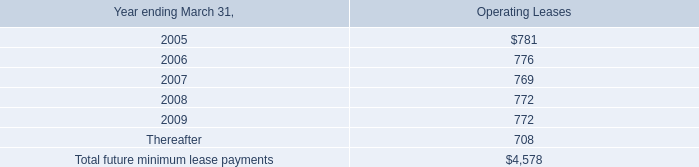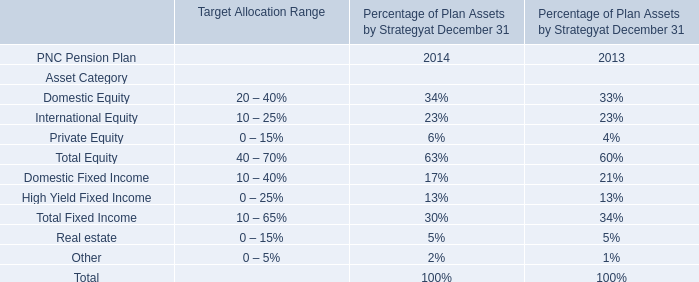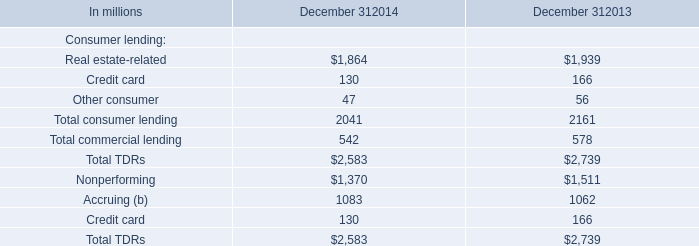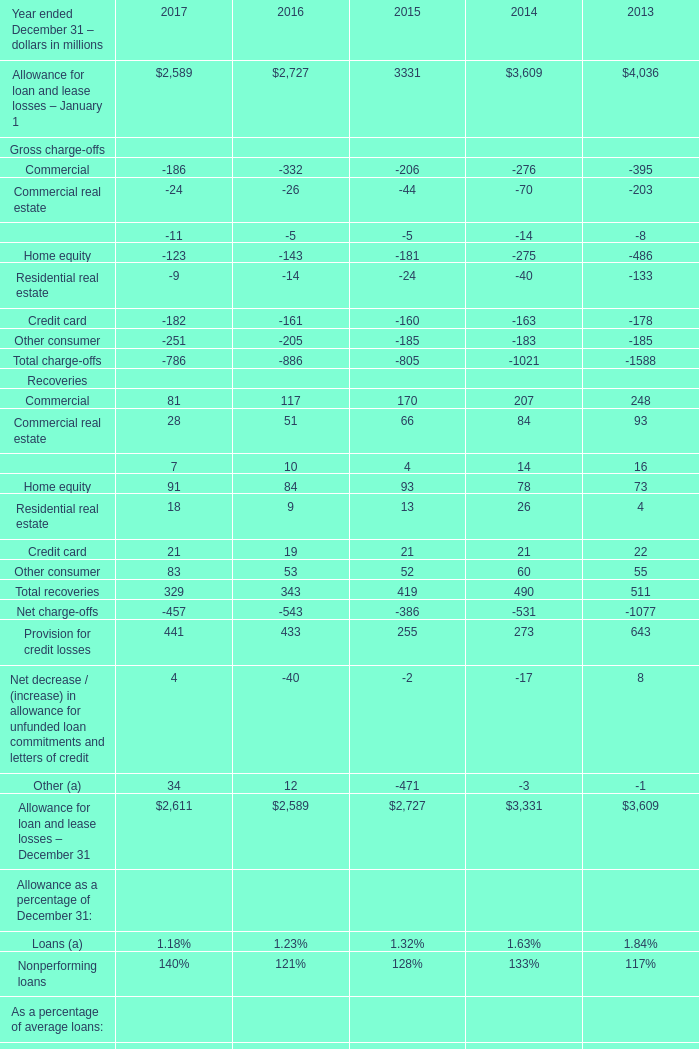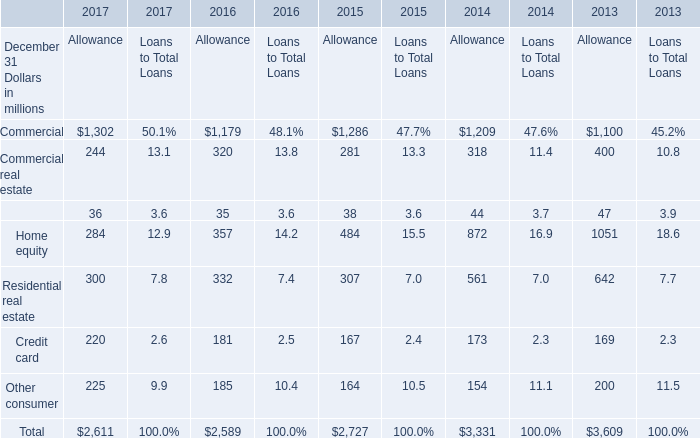What is the ratio of all elements for Allowance that are smaller than 300 to the sum of elements in 2016? 
Computations: (((35 + 181) + 185) / 2589)
Answer: 0.15489. 